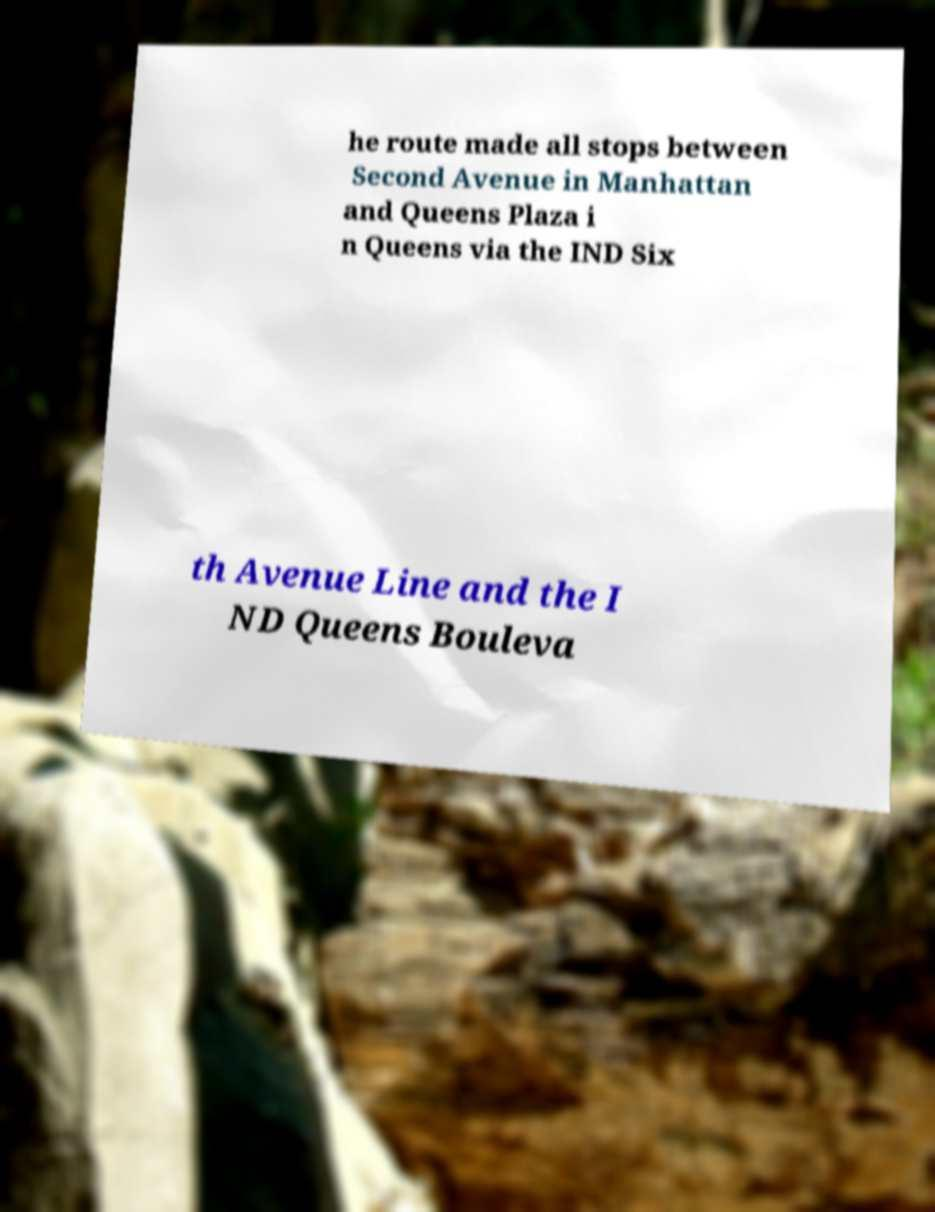Could you assist in decoding the text presented in this image and type it out clearly? he route made all stops between Second Avenue in Manhattan and Queens Plaza i n Queens via the IND Six th Avenue Line and the I ND Queens Bouleva 